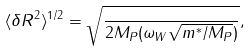<formula> <loc_0><loc_0><loc_500><loc_500>\langle \delta R ^ { 2 } \rangle ^ { 1 / 2 } = \sqrt { \frac { } { 2 M _ { P } ( \omega _ { W } \sqrt { m ^ { * } / M _ { P } } ) } } ,</formula> 